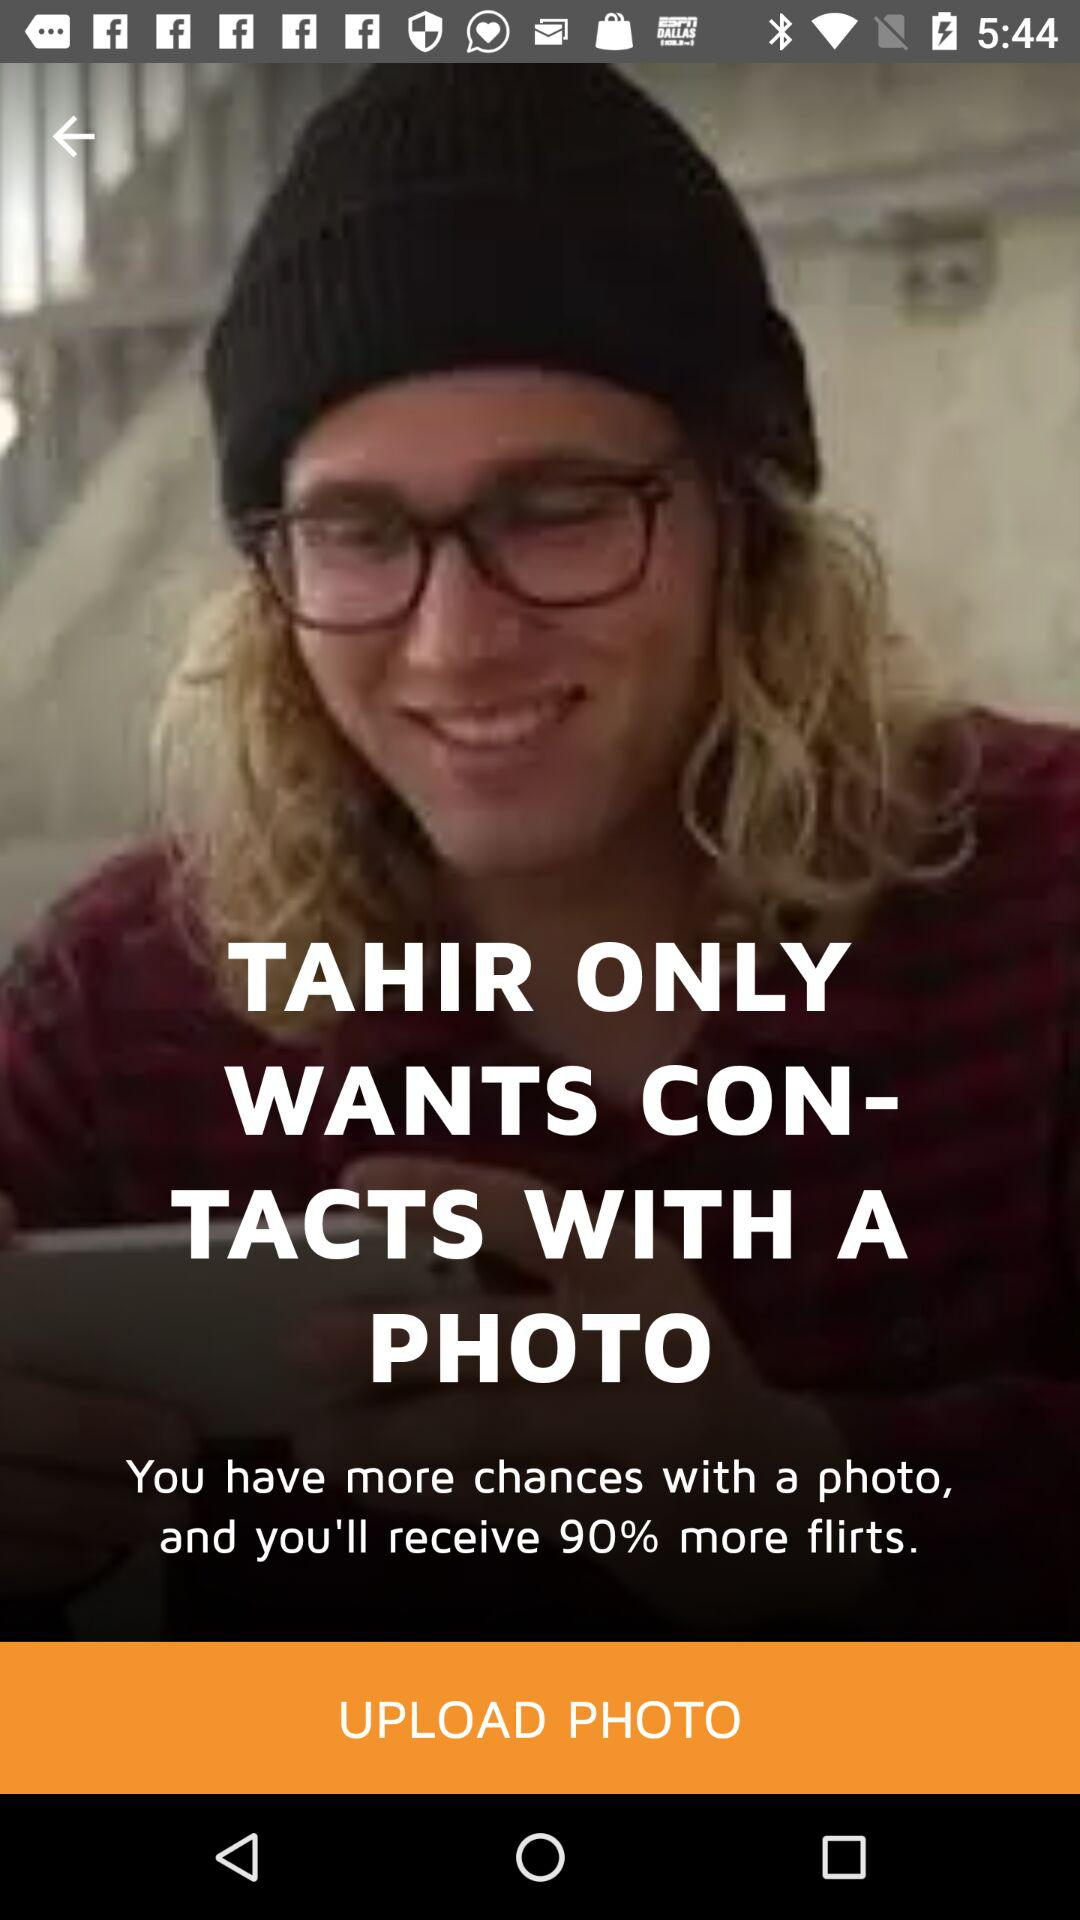How many more flirts will I receive if I upload a photo?
Answer the question using a single word or phrase. 90% 